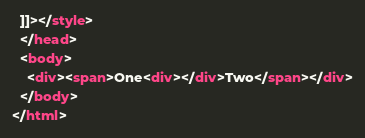Convert code to text. <code><loc_0><loc_0><loc_500><loc_500><_HTML_>  ]]></style>
  </head>
  <body>
    <div><span>One<div></div>Two</span></div>
  </body>
</html>
</code> 